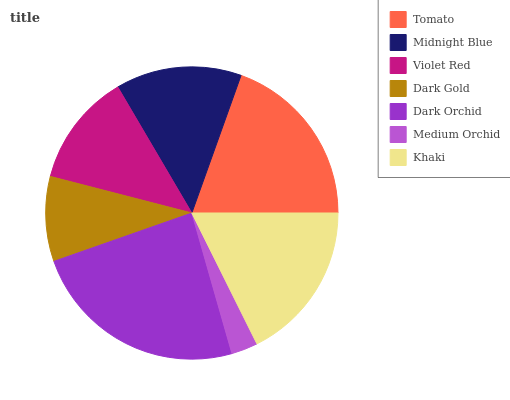Is Medium Orchid the minimum?
Answer yes or no. Yes. Is Dark Orchid the maximum?
Answer yes or no. Yes. Is Midnight Blue the minimum?
Answer yes or no. No. Is Midnight Blue the maximum?
Answer yes or no. No. Is Tomato greater than Midnight Blue?
Answer yes or no. Yes. Is Midnight Blue less than Tomato?
Answer yes or no. Yes. Is Midnight Blue greater than Tomato?
Answer yes or no. No. Is Tomato less than Midnight Blue?
Answer yes or no. No. Is Midnight Blue the high median?
Answer yes or no. Yes. Is Midnight Blue the low median?
Answer yes or no. Yes. Is Dark Orchid the high median?
Answer yes or no. No. Is Dark Gold the low median?
Answer yes or no. No. 